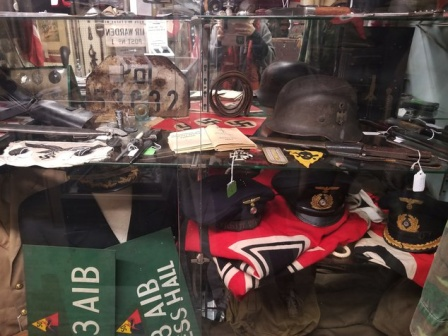What era does the displayed memorabilia belong to, and what significance does each item hold? The memorabilia appears to predominantly belong to the World War II era, a time marked by global conflict and significant historical events. The black metal helmet likely represents a type of combat headgear used by soldiers, providing crucial protection on the battlefield. The rifle, noted for its detailed construction, is a testament to the weaponry advances of that period. The flag with its '3AIB' and 'ABN' inscriptions possibly signifies specific military battalions or units, denoting organizational pride and identity. The yellow book 'WORLD WAR II' serves as a poignant reminder of the educational drive to document and understand this pivotal era. Each artifact encapsulates a fragment of history, from the battles fought to the soldiers' stories, collectively narrating the saga of the times they represent. How might these items have been used or experienced by people during the war? During the war, the items on display likely played vital roles on various fronts. The helmet would have been a standard issue for soldiers heading into combat, providing crucial head protection amidst the dangers of warfare. The rifle, with its intricate craftsmanship, was likely a trusted weapon in the hands of soldiers, essential for both defending against enemy forces and executing strategic offensives. The flag symbolizes unit cohesion and morale, potentially flown during operations or ceremonious gatherings to evoke a sense of unity and purpose. The book, although not directly used during the conflict, represents the scholarly pursuit that followed, as historians and researchers endeavored to document and analyze the monumental events of World War II. Collectively, these items not only facilitated wartime activities but also symbolized the resilience and determination of those embroiled in the conflict. Imagine if one of these items could speak. What story might it tell? If the rifle could speak, it might recount harrowing tales from the battlefield. It could describe the first time it was fired in the heat of battle, its barrel heating up as soldiers engaged in fierce skirmishes. It would speak of the hands that held it—trembling with fear at first, but growing steadier with each passing day. The rifle might recount moments of triumph, where its precision turned the tide of a confrontation, and moments of sorrow, where it witnessed the fall of comrades. It would convey the camaraderie among soldiers, the shared burdens, and the silent promises made in the thick of dust and gunfire. It would tell of the nights spent in trenches, the rain that fell, the mud that clung, and the relentless spirit of survival among its bearers. Through its sights, the rifle has seen the breadth of human emotion—from the horrors of war to the relief of survival, encapsulating the paradoxes of bravery and vulnerability. 